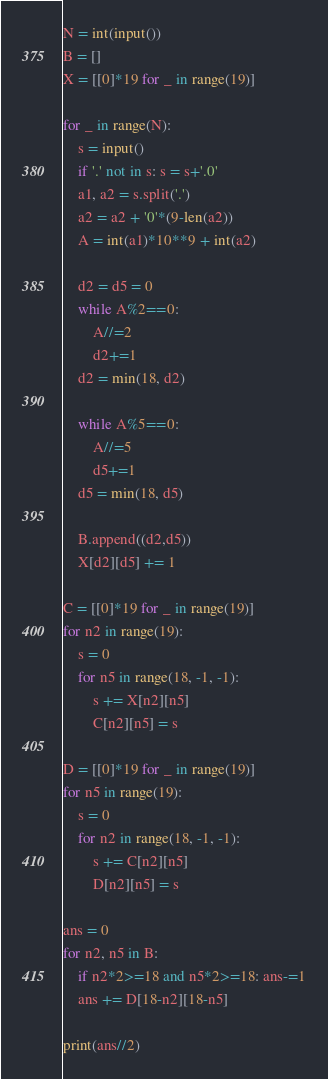<code> <loc_0><loc_0><loc_500><loc_500><_Python_>N = int(input())
B = []
X = [[0]*19 for _ in range(19)]

for _ in range(N):
    s = input()
    if '.' not in s: s = s+'.0'
    a1, a2 = s.split('.')
    a2 = a2 + '0'*(9-len(a2))
    A = int(a1)*10**9 + int(a2)

    d2 = d5 = 0
    while A%2==0:
        A//=2
        d2+=1
    d2 = min(18, d2)

    while A%5==0:
        A//=5
        d5+=1
    d5 = min(18, d5)

    B.append((d2,d5))
    X[d2][d5] += 1

C = [[0]*19 for _ in range(19)]
for n2 in range(19):
    s = 0
    for n5 in range(18, -1, -1):
        s += X[n2][n5]
        C[n2][n5] = s

D = [[0]*19 for _ in range(19)]
for n5 in range(19):
    s = 0
    for n2 in range(18, -1, -1):
        s += C[n2][n5]
        D[n2][n5] = s

ans = 0
for n2, n5 in B:
    if n2*2>=18 and n5*2>=18: ans-=1
    ans += D[18-n2][18-n5]
    
print(ans//2)
</code> 